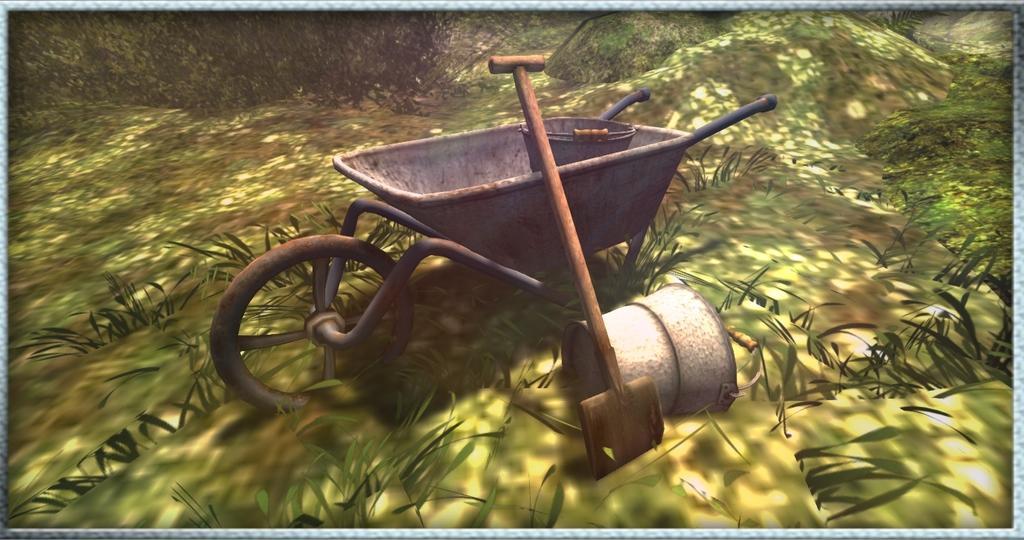In one or two sentences, can you explain what this image depicts? This is an animation picture. In this there is a wheelbarrow. There is a bucket in that. Near to that there is a spade and a bucket. On the ground there is grass. 